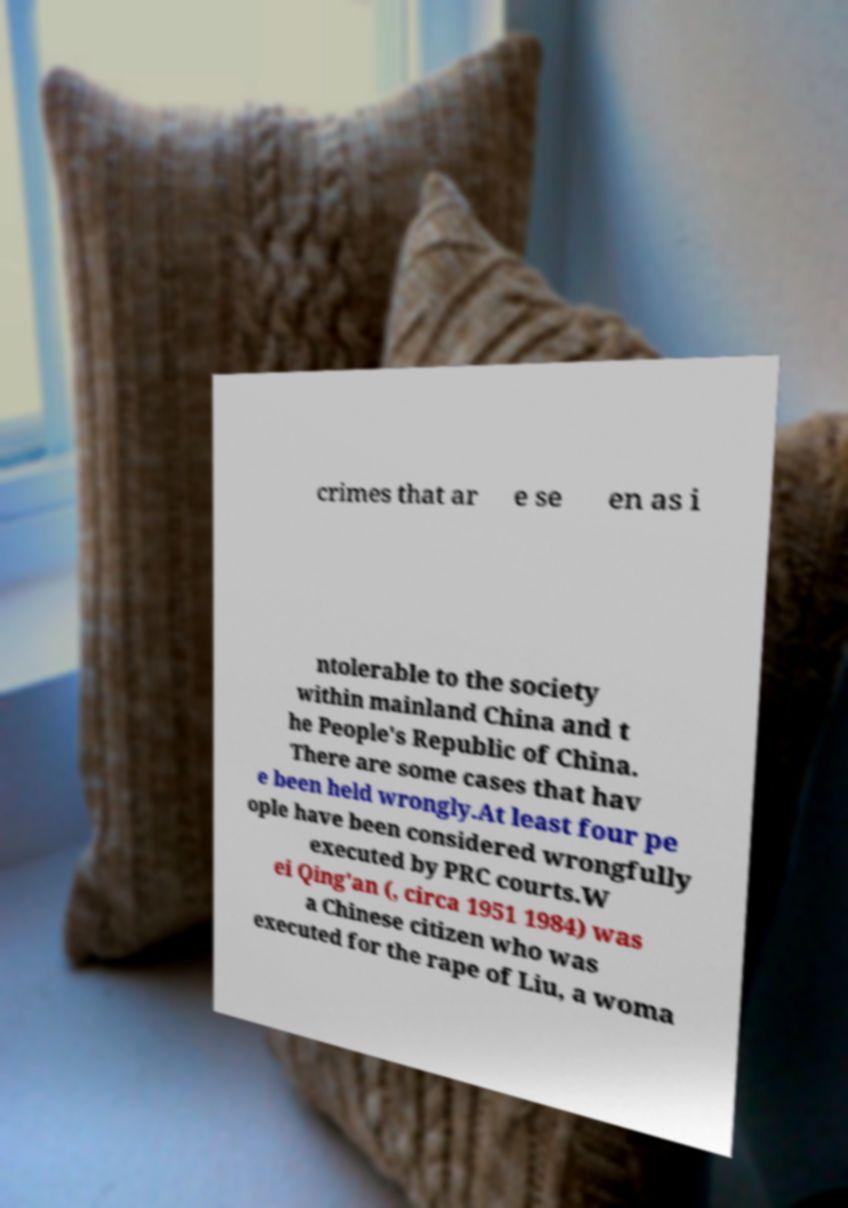Please read and relay the text visible in this image. What does it say? crimes that ar e se en as i ntolerable to the society within mainland China and t he People's Republic of China. There are some cases that hav e been held wrongly.At least four pe ople have been considered wrongfully executed by PRC courts.W ei Qing'an (, circa 1951 1984) was a Chinese citizen who was executed for the rape of Liu, a woma 